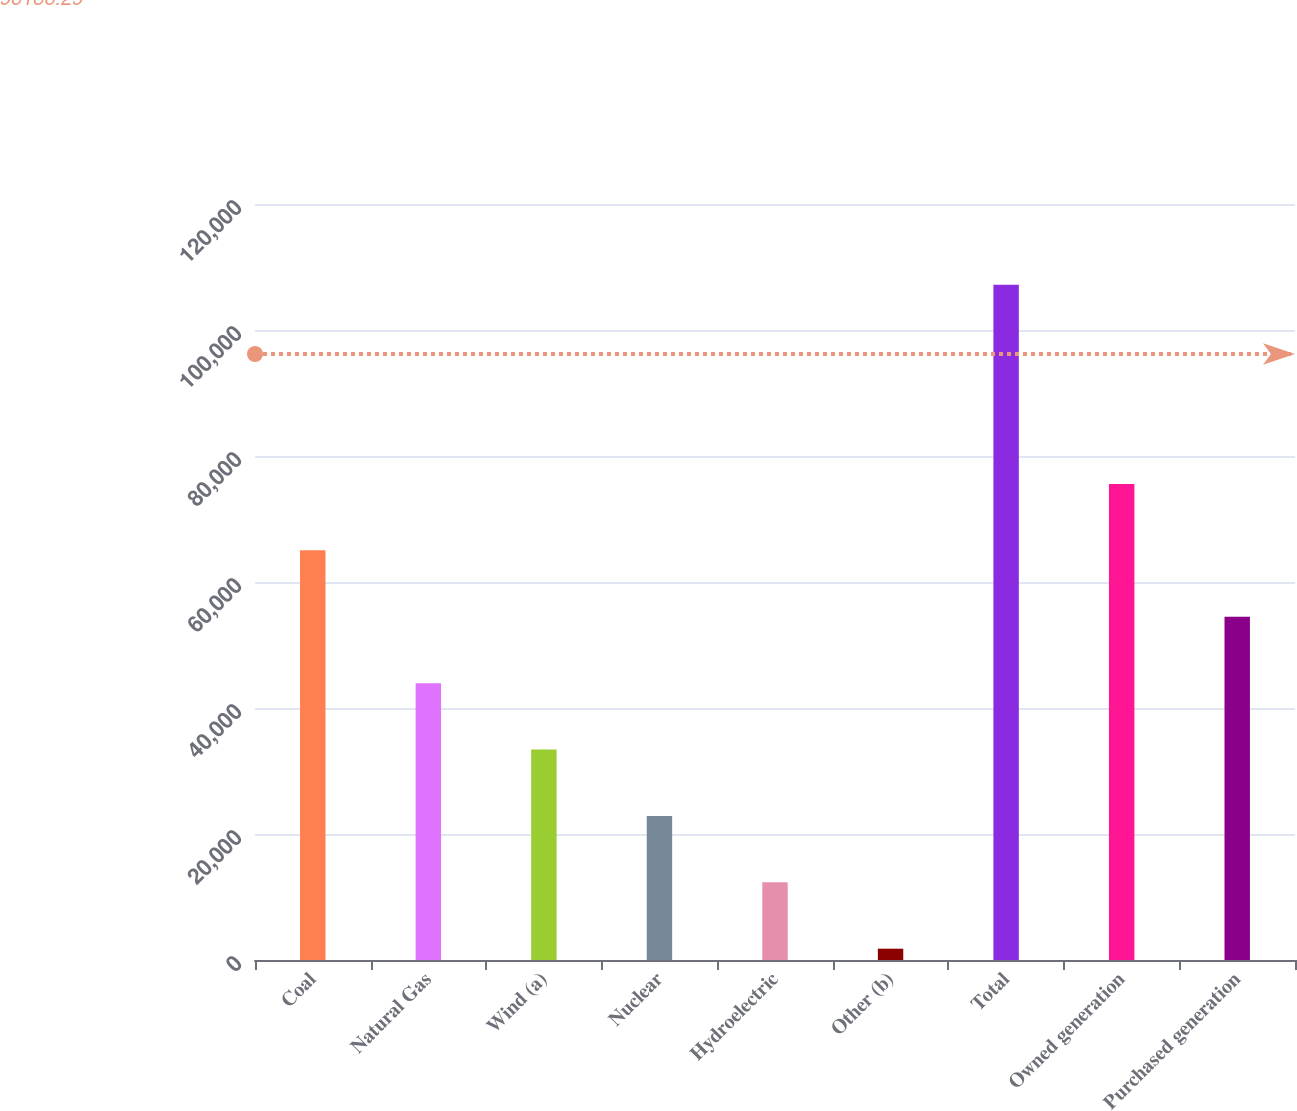<chart> <loc_0><loc_0><loc_500><loc_500><bar_chart><fcel>Coal<fcel>Natural Gas<fcel>Wind (a)<fcel>Nuclear<fcel>Hydroelectric<fcel>Other (b)<fcel>Total<fcel>Owned generation<fcel>Purchased generation<nl><fcel>65021.8<fcel>43946.2<fcel>33408.4<fcel>22870.6<fcel>12332.8<fcel>1795<fcel>107173<fcel>75559.6<fcel>54484<nl></chart> 